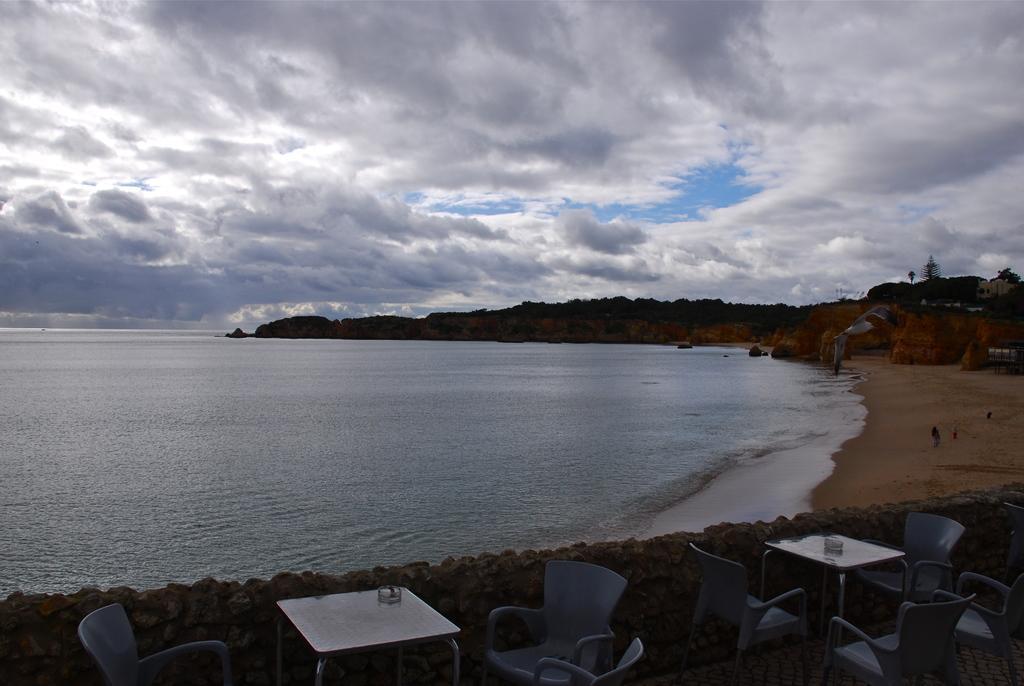In one or two sentences, can you explain what this image depicts? In this image I can see few chairs, tables, stones, trees, water and rocks. The sky is in blue and white color. 